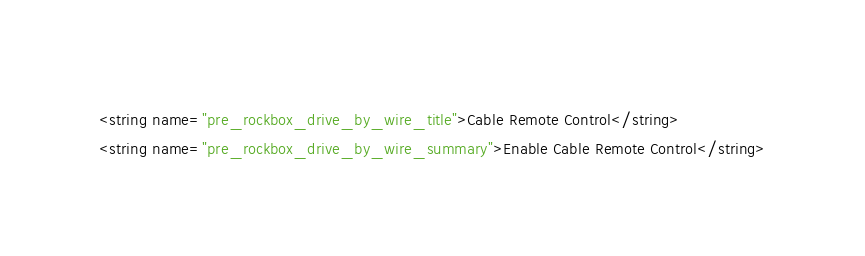<code> <loc_0><loc_0><loc_500><loc_500><_XML_><string name="pre_rockbox_drive_by_wire_title">Cable Remote Control</string>
<string name="pre_rockbox_drive_by_wire_summary">Enable Cable Remote Control</string></code> 